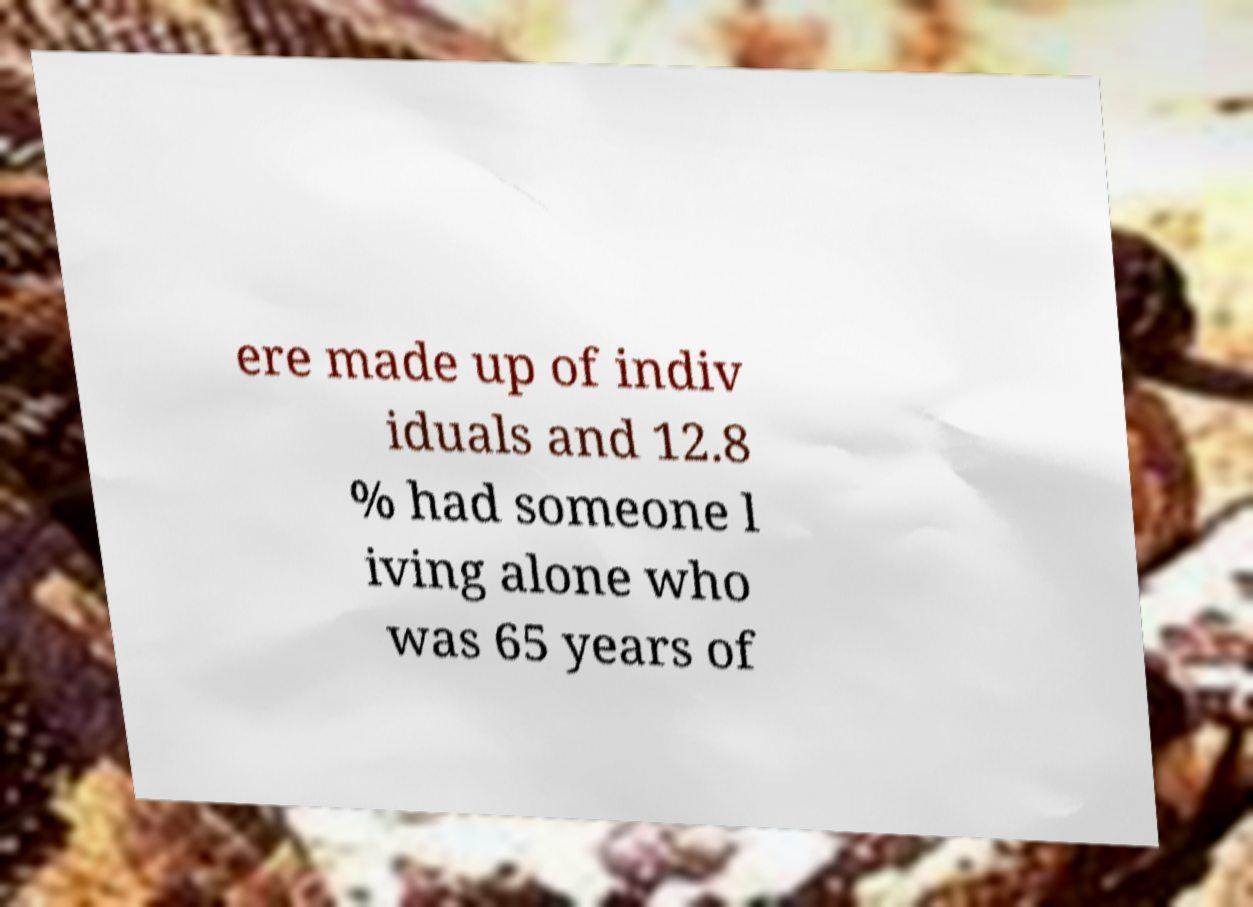What messages or text are displayed in this image? I need them in a readable, typed format. ere made up of indiv iduals and 12.8 % had someone l iving alone who was 65 years of 